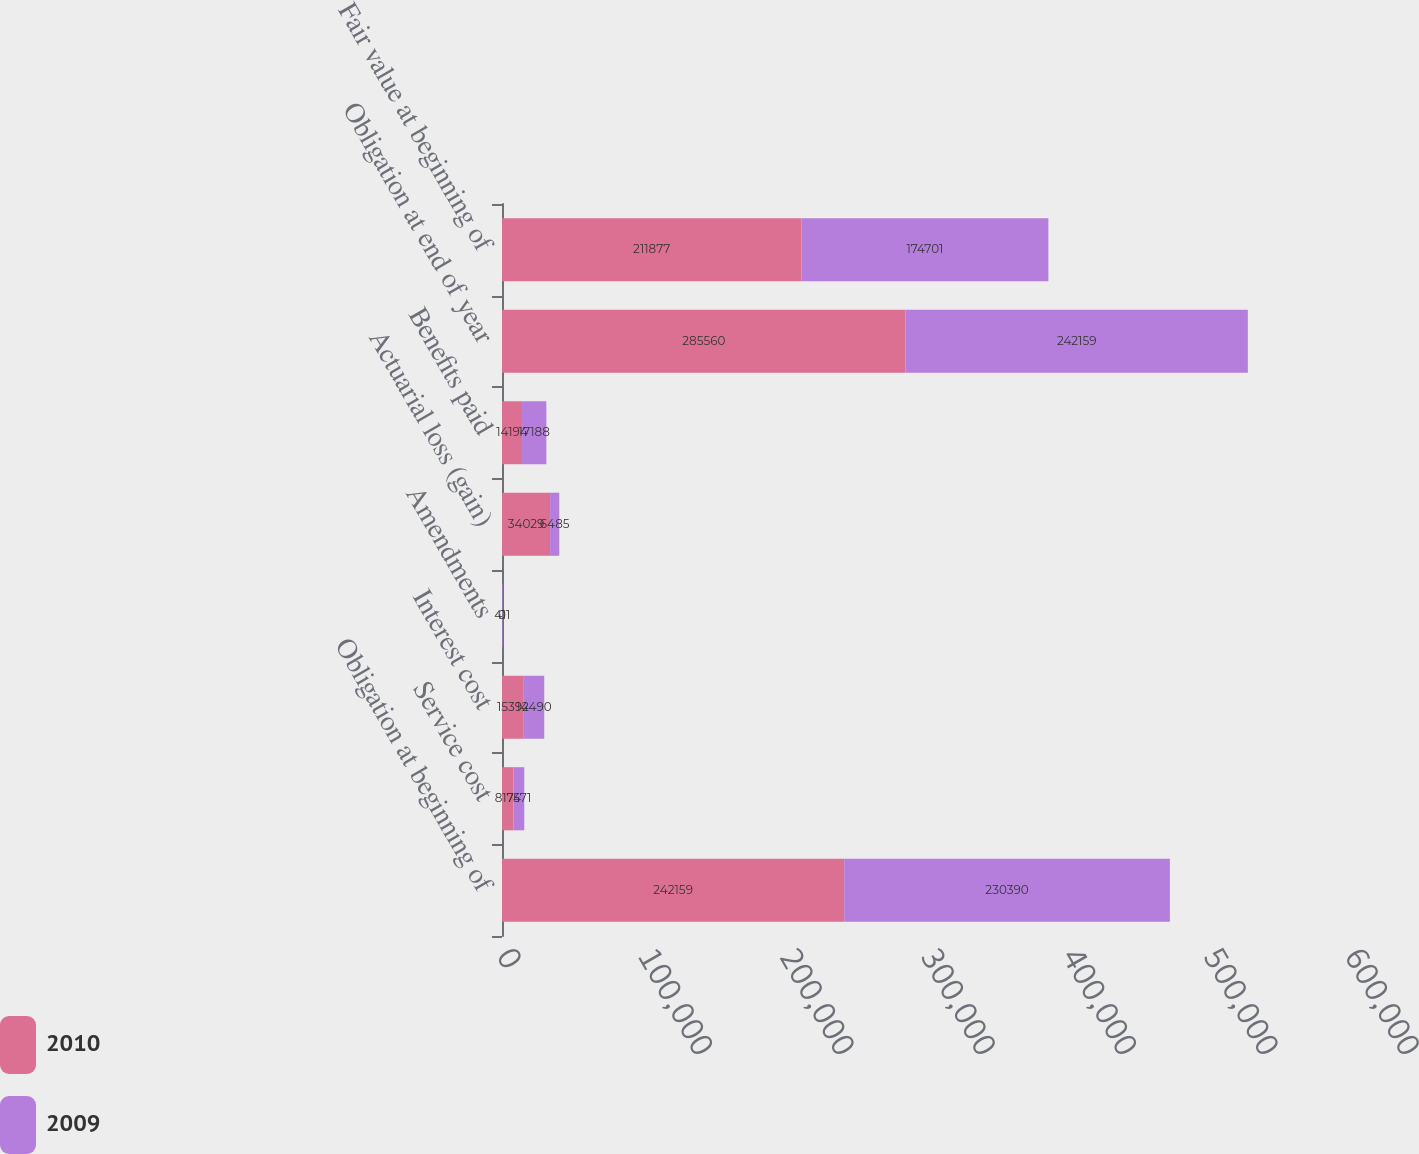<chart> <loc_0><loc_0><loc_500><loc_500><stacked_bar_chart><ecel><fcel>Obligation at beginning of<fcel>Service cost<fcel>Interest cost<fcel>Amendments<fcel>Actuarial loss (gain)<fcel>Benefits paid<fcel>Obligation at end of year<fcel>Fair value at beginning of<nl><fcel>2010<fcel>242159<fcel>8174<fcel>15392<fcel>0<fcel>34029<fcel>14194<fcel>285560<fcel>211877<nl><fcel>2009<fcel>230390<fcel>7571<fcel>14490<fcel>411<fcel>6485<fcel>17188<fcel>242159<fcel>174701<nl></chart> 